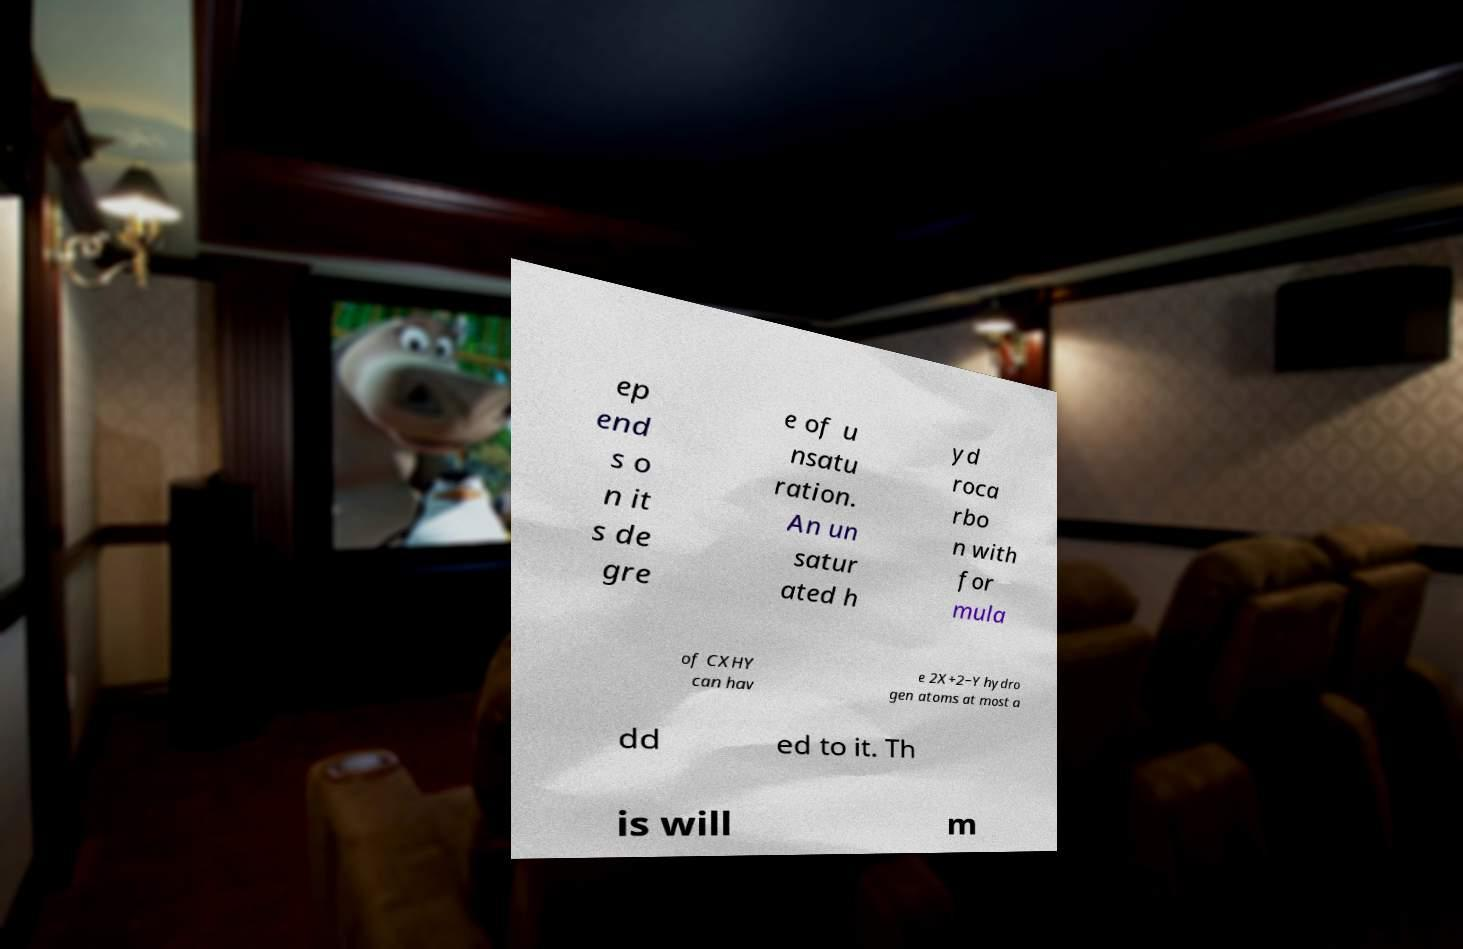Can you accurately transcribe the text from the provided image for me? ep end s o n it s de gre e of u nsatu ration. An un satur ated h yd roca rbo n with for mula of CXHY can hav e 2X+2−Y hydro gen atoms at most a dd ed to it. Th is will m 